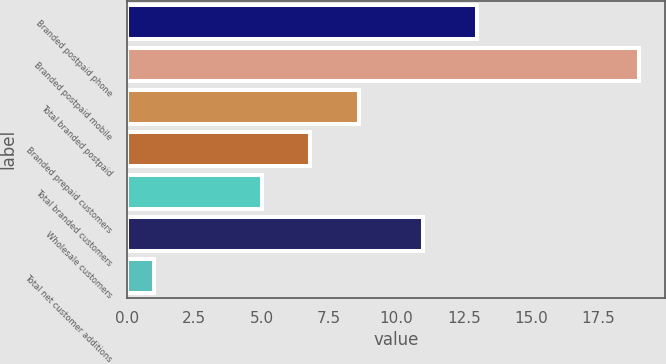Convert chart to OTSL. <chart><loc_0><loc_0><loc_500><loc_500><bar_chart><fcel>Branded postpaid phone<fcel>Branded postpaid mobile<fcel>Total branded postpaid<fcel>Branded prepaid customers<fcel>Total branded customers<fcel>Wholesale customers<fcel>Total net customer additions<nl><fcel>13<fcel>19<fcel>8.6<fcel>6.8<fcel>5<fcel>11<fcel>1<nl></chart> 